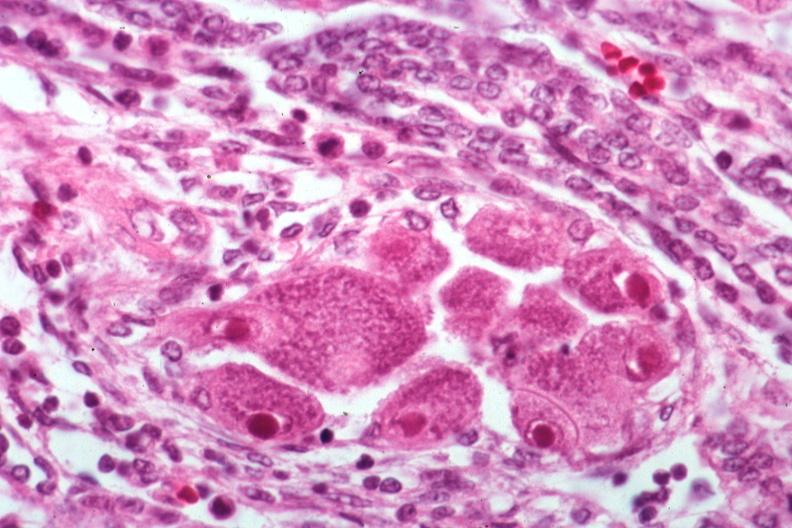where is this?
Answer the question using a single word or phrase. Urinary 